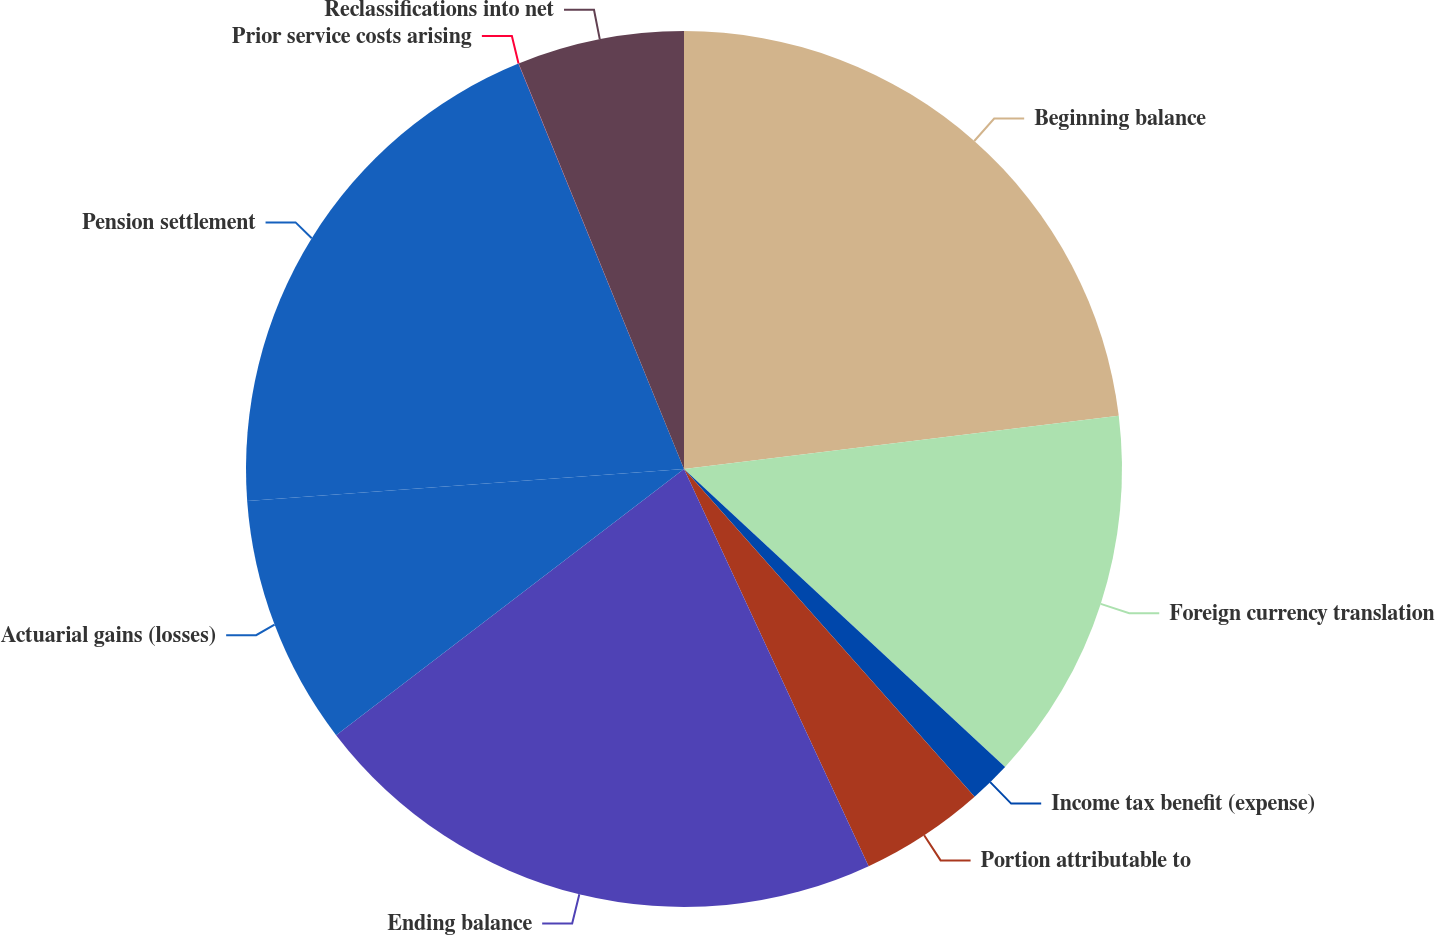<chart> <loc_0><loc_0><loc_500><loc_500><pie_chart><fcel>Beginning balance<fcel>Foreign currency translation<fcel>Income tax benefit (expense)<fcel>Portion attributable to<fcel>Ending balance<fcel>Actuarial gains (losses)<fcel>Pension settlement<fcel>Prior service costs arising<fcel>Reclassifications into net<nl><fcel>23.06%<fcel>13.84%<fcel>1.55%<fcel>4.62%<fcel>21.53%<fcel>9.23%<fcel>19.99%<fcel>0.01%<fcel>6.16%<nl></chart> 